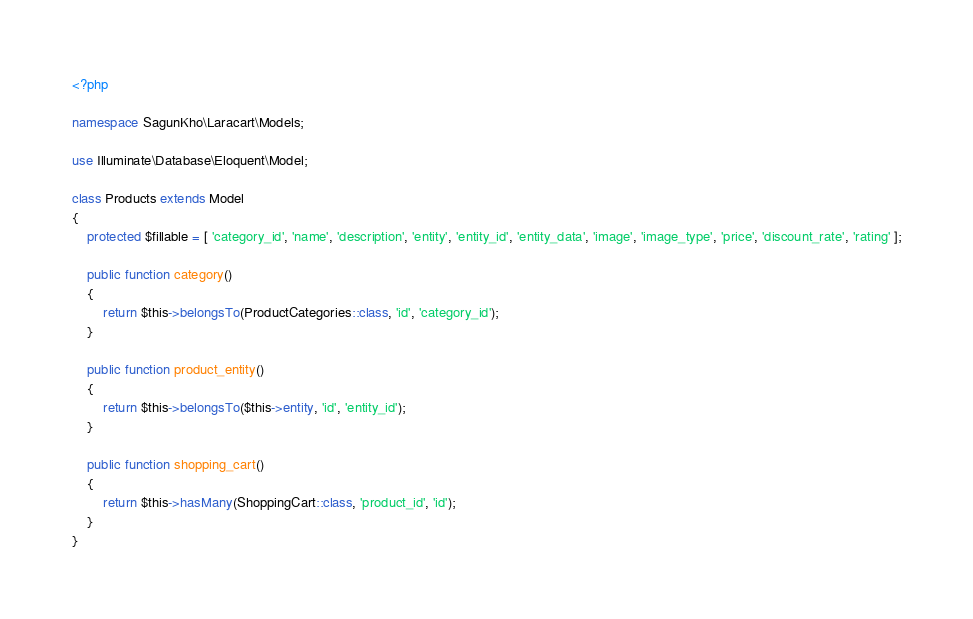Convert code to text. <code><loc_0><loc_0><loc_500><loc_500><_PHP_><?php

namespace SagunKho\Laracart\Models;

use Illuminate\Database\Eloquent\Model;

class Products extends Model
{
	protected $fillable = [ 'category_id', 'name', 'description', 'entity', 'entity_id', 'entity_data', 'image', 'image_type', 'price', 'discount_rate', 'rating' ];

	public function category()
	{
		return $this->belongsTo(ProductCategories::class, 'id', 'category_id');
	}

	public function product_entity()
	{
		return $this->belongsTo($this->entity, 'id', 'entity_id');
	}

	public function shopping_cart()
	{
		return $this->hasMany(ShoppingCart::class, 'product_id', 'id');
	}
}
</code> 